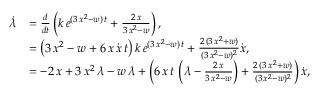Convert formula to latex. <formula><loc_0><loc_0><loc_500><loc_500>\begin{array} { r l } { \dot { \lambda } } & { = \frac { d } { d t } \left ( k \, e ^ { ( 3 \, x ^ { 2 } - w ) \, t } + \frac { 2 \, x } { 3 \, x ^ { 2 } - w } \right ) , } \\ & { = \left ( 3 \, x ^ { 2 } - w + 6 \, x \, \dot { x } \, t \right ) k \, e ^ { ( 3 \, x ^ { 2 } - w ) \, t } + \frac { 2 \, ( 3 \, x ^ { 2 } + w ) } { ( 3 \, x ^ { 2 } - w ) ^ { 2 } } \dot { x } , } \\ & { = - 2 \, x + 3 \, x ^ { 2 } \, \lambda - w \, \lambda + \left ( 6 \, x \, t \, \left ( \lambda - \frac { 2 \, x } { 3 \, x ^ { 2 } - w } \right ) + \frac { 2 \, ( 3 \, x ^ { 2 } + w ) } { ( 3 \, x ^ { 2 } - w ) ^ { 2 } } \right ) \dot { x } , } \end{array}</formula> 